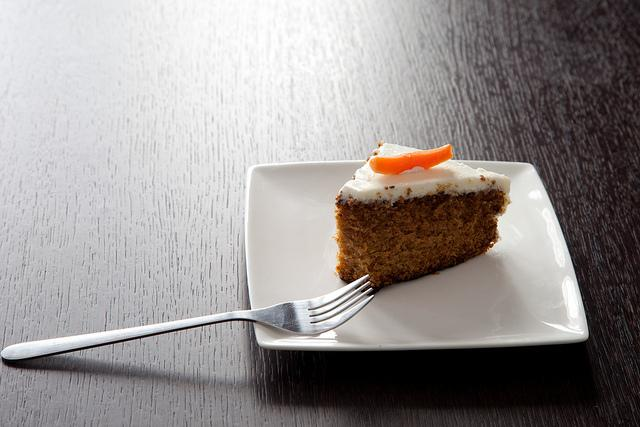What kind of cake has been served?

Choices:
A) cinnamon
B) red velvet
C) chocolate
D) carrot carrot 